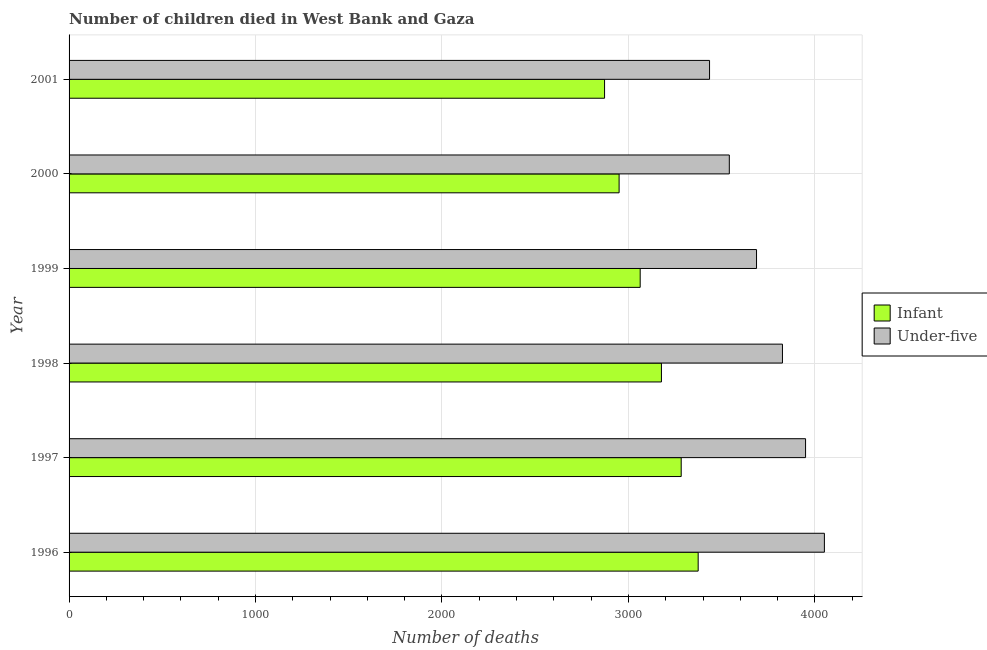Are the number of bars on each tick of the Y-axis equal?
Keep it short and to the point. Yes. How many bars are there on the 4th tick from the bottom?
Keep it short and to the point. 2. In how many cases, is the number of bars for a given year not equal to the number of legend labels?
Your response must be concise. 0. What is the number of under-five deaths in 1998?
Provide a succinct answer. 3826. Across all years, what is the maximum number of under-five deaths?
Make the answer very short. 4051. Across all years, what is the minimum number of infant deaths?
Your answer should be very brief. 2872. In which year was the number of infant deaths minimum?
Your response must be concise. 2001. What is the total number of infant deaths in the graph?
Offer a very short reply. 1.87e+04. What is the difference between the number of under-five deaths in 1996 and that in 2000?
Provide a short and direct response. 510. What is the difference between the number of under-five deaths in 1999 and the number of infant deaths in 2000?
Your response must be concise. 737. What is the average number of infant deaths per year?
Give a very brief answer. 3119.83. In the year 2000, what is the difference between the number of infant deaths and number of under-five deaths?
Provide a short and direct response. -591. In how many years, is the number of under-five deaths greater than 600 ?
Provide a succinct answer. 6. What is the ratio of the number of infant deaths in 2000 to that in 2001?
Your response must be concise. 1.03. Is the difference between the number of under-five deaths in 1996 and 2001 greater than the difference between the number of infant deaths in 1996 and 2001?
Make the answer very short. Yes. What is the difference between the highest and the second highest number of infant deaths?
Ensure brevity in your answer.  91. What is the difference between the highest and the lowest number of infant deaths?
Keep it short and to the point. 502. In how many years, is the number of under-five deaths greater than the average number of under-five deaths taken over all years?
Your answer should be very brief. 3. What does the 1st bar from the top in 1998 represents?
Your answer should be very brief. Under-five. What does the 2nd bar from the bottom in 1998 represents?
Give a very brief answer. Under-five. Are all the bars in the graph horizontal?
Your answer should be compact. Yes. Are the values on the major ticks of X-axis written in scientific E-notation?
Give a very brief answer. No. Does the graph contain any zero values?
Your answer should be very brief. No. Where does the legend appear in the graph?
Keep it short and to the point. Center right. How are the legend labels stacked?
Make the answer very short. Vertical. What is the title of the graph?
Make the answer very short. Number of children died in West Bank and Gaza. What is the label or title of the X-axis?
Make the answer very short. Number of deaths. What is the Number of deaths of Infant in 1996?
Keep it short and to the point. 3374. What is the Number of deaths of Under-five in 1996?
Your answer should be very brief. 4051. What is the Number of deaths in Infant in 1997?
Provide a short and direct response. 3283. What is the Number of deaths of Under-five in 1997?
Provide a short and direct response. 3950. What is the Number of deaths in Infant in 1998?
Offer a very short reply. 3177. What is the Number of deaths in Under-five in 1998?
Ensure brevity in your answer.  3826. What is the Number of deaths of Infant in 1999?
Ensure brevity in your answer.  3063. What is the Number of deaths in Under-five in 1999?
Offer a very short reply. 3687. What is the Number of deaths in Infant in 2000?
Offer a very short reply. 2950. What is the Number of deaths of Under-five in 2000?
Offer a terse response. 3541. What is the Number of deaths in Infant in 2001?
Keep it short and to the point. 2872. What is the Number of deaths of Under-five in 2001?
Give a very brief answer. 3435. Across all years, what is the maximum Number of deaths of Infant?
Your response must be concise. 3374. Across all years, what is the maximum Number of deaths in Under-five?
Your answer should be very brief. 4051. Across all years, what is the minimum Number of deaths of Infant?
Provide a succinct answer. 2872. Across all years, what is the minimum Number of deaths of Under-five?
Make the answer very short. 3435. What is the total Number of deaths in Infant in the graph?
Make the answer very short. 1.87e+04. What is the total Number of deaths in Under-five in the graph?
Offer a terse response. 2.25e+04. What is the difference between the Number of deaths of Infant in 1996 and that in 1997?
Your response must be concise. 91. What is the difference between the Number of deaths in Under-five in 1996 and that in 1997?
Offer a terse response. 101. What is the difference between the Number of deaths in Infant in 1996 and that in 1998?
Provide a short and direct response. 197. What is the difference between the Number of deaths of Under-five in 1996 and that in 1998?
Provide a short and direct response. 225. What is the difference between the Number of deaths in Infant in 1996 and that in 1999?
Offer a very short reply. 311. What is the difference between the Number of deaths of Under-five in 1996 and that in 1999?
Offer a terse response. 364. What is the difference between the Number of deaths of Infant in 1996 and that in 2000?
Make the answer very short. 424. What is the difference between the Number of deaths in Under-five in 1996 and that in 2000?
Give a very brief answer. 510. What is the difference between the Number of deaths of Infant in 1996 and that in 2001?
Ensure brevity in your answer.  502. What is the difference between the Number of deaths in Under-five in 1996 and that in 2001?
Ensure brevity in your answer.  616. What is the difference between the Number of deaths of Infant in 1997 and that in 1998?
Keep it short and to the point. 106. What is the difference between the Number of deaths in Under-five in 1997 and that in 1998?
Offer a very short reply. 124. What is the difference between the Number of deaths in Infant in 1997 and that in 1999?
Offer a terse response. 220. What is the difference between the Number of deaths in Under-five in 1997 and that in 1999?
Offer a terse response. 263. What is the difference between the Number of deaths in Infant in 1997 and that in 2000?
Your answer should be compact. 333. What is the difference between the Number of deaths in Under-five in 1997 and that in 2000?
Provide a succinct answer. 409. What is the difference between the Number of deaths in Infant in 1997 and that in 2001?
Offer a terse response. 411. What is the difference between the Number of deaths in Under-five in 1997 and that in 2001?
Ensure brevity in your answer.  515. What is the difference between the Number of deaths in Infant in 1998 and that in 1999?
Your answer should be very brief. 114. What is the difference between the Number of deaths of Under-five in 1998 and that in 1999?
Offer a very short reply. 139. What is the difference between the Number of deaths of Infant in 1998 and that in 2000?
Your answer should be compact. 227. What is the difference between the Number of deaths of Under-five in 1998 and that in 2000?
Provide a succinct answer. 285. What is the difference between the Number of deaths of Infant in 1998 and that in 2001?
Offer a very short reply. 305. What is the difference between the Number of deaths in Under-five in 1998 and that in 2001?
Offer a very short reply. 391. What is the difference between the Number of deaths in Infant in 1999 and that in 2000?
Give a very brief answer. 113. What is the difference between the Number of deaths of Under-five in 1999 and that in 2000?
Your response must be concise. 146. What is the difference between the Number of deaths of Infant in 1999 and that in 2001?
Offer a very short reply. 191. What is the difference between the Number of deaths in Under-five in 1999 and that in 2001?
Ensure brevity in your answer.  252. What is the difference between the Number of deaths of Infant in 2000 and that in 2001?
Your answer should be compact. 78. What is the difference between the Number of deaths of Under-five in 2000 and that in 2001?
Your response must be concise. 106. What is the difference between the Number of deaths of Infant in 1996 and the Number of deaths of Under-five in 1997?
Give a very brief answer. -576. What is the difference between the Number of deaths in Infant in 1996 and the Number of deaths in Under-five in 1998?
Give a very brief answer. -452. What is the difference between the Number of deaths of Infant in 1996 and the Number of deaths of Under-five in 1999?
Make the answer very short. -313. What is the difference between the Number of deaths of Infant in 1996 and the Number of deaths of Under-five in 2000?
Keep it short and to the point. -167. What is the difference between the Number of deaths of Infant in 1996 and the Number of deaths of Under-five in 2001?
Provide a short and direct response. -61. What is the difference between the Number of deaths in Infant in 1997 and the Number of deaths in Under-five in 1998?
Your response must be concise. -543. What is the difference between the Number of deaths of Infant in 1997 and the Number of deaths of Under-five in 1999?
Offer a terse response. -404. What is the difference between the Number of deaths in Infant in 1997 and the Number of deaths in Under-five in 2000?
Your response must be concise. -258. What is the difference between the Number of deaths of Infant in 1997 and the Number of deaths of Under-five in 2001?
Make the answer very short. -152. What is the difference between the Number of deaths of Infant in 1998 and the Number of deaths of Under-five in 1999?
Give a very brief answer. -510. What is the difference between the Number of deaths of Infant in 1998 and the Number of deaths of Under-five in 2000?
Provide a succinct answer. -364. What is the difference between the Number of deaths of Infant in 1998 and the Number of deaths of Under-five in 2001?
Provide a succinct answer. -258. What is the difference between the Number of deaths in Infant in 1999 and the Number of deaths in Under-five in 2000?
Keep it short and to the point. -478. What is the difference between the Number of deaths of Infant in 1999 and the Number of deaths of Under-five in 2001?
Your answer should be compact. -372. What is the difference between the Number of deaths in Infant in 2000 and the Number of deaths in Under-five in 2001?
Your answer should be very brief. -485. What is the average Number of deaths in Infant per year?
Provide a short and direct response. 3119.83. What is the average Number of deaths of Under-five per year?
Offer a very short reply. 3748.33. In the year 1996, what is the difference between the Number of deaths in Infant and Number of deaths in Under-five?
Keep it short and to the point. -677. In the year 1997, what is the difference between the Number of deaths in Infant and Number of deaths in Under-five?
Offer a very short reply. -667. In the year 1998, what is the difference between the Number of deaths of Infant and Number of deaths of Under-five?
Make the answer very short. -649. In the year 1999, what is the difference between the Number of deaths of Infant and Number of deaths of Under-five?
Ensure brevity in your answer.  -624. In the year 2000, what is the difference between the Number of deaths of Infant and Number of deaths of Under-five?
Provide a succinct answer. -591. In the year 2001, what is the difference between the Number of deaths of Infant and Number of deaths of Under-five?
Provide a succinct answer. -563. What is the ratio of the Number of deaths of Infant in 1996 to that in 1997?
Offer a terse response. 1.03. What is the ratio of the Number of deaths in Under-five in 1996 to that in 1997?
Make the answer very short. 1.03. What is the ratio of the Number of deaths of Infant in 1996 to that in 1998?
Make the answer very short. 1.06. What is the ratio of the Number of deaths in Under-five in 1996 to that in 1998?
Your response must be concise. 1.06. What is the ratio of the Number of deaths of Infant in 1996 to that in 1999?
Your response must be concise. 1.1. What is the ratio of the Number of deaths of Under-five in 1996 to that in 1999?
Ensure brevity in your answer.  1.1. What is the ratio of the Number of deaths in Infant in 1996 to that in 2000?
Keep it short and to the point. 1.14. What is the ratio of the Number of deaths in Under-five in 1996 to that in 2000?
Your response must be concise. 1.14. What is the ratio of the Number of deaths in Infant in 1996 to that in 2001?
Give a very brief answer. 1.17. What is the ratio of the Number of deaths in Under-five in 1996 to that in 2001?
Your response must be concise. 1.18. What is the ratio of the Number of deaths in Infant in 1997 to that in 1998?
Keep it short and to the point. 1.03. What is the ratio of the Number of deaths in Under-five in 1997 to that in 1998?
Your answer should be compact. 1.03. What is the ratio of the Number of deaths in Infant in 1997 to that in 1999?
Your response must be concise. 1.07. What is the ratio of the Number of deaths of Under-five in 1997 to that in 1999?
Ensure brevity in your answer.  1.07. What is the ratio of the Number of deaths of Infant in 1997 to that in 2000?
Provide a short and direct response. 1.11. What is the ratio of the Number of deaths of Under-five in 1997 to that in 2000?
Your response must be concise. 1.12. What is the ratio of the Number of deaths of Infant in 1997 to that in 2001?
Ensure brevity in your answer.  1.14. What is the ratio of the Number of deaths of Under-five in 1997 to that in 2001?
Make the answer very short. 1.15. What is the ratio of the Number of deaths of Infant in 1998 to that in 1999?
Keep it short and to the point. 1.04. What is the ratio of the Number of deaths in Under-five in 1998 to that in 1999?
Your answer should be compact. 1.04. What is the ratio of the Number of deaths in Infant in 1998 to that in 2000?
Your response must be concise. 1.08. What is the ratio of the Number of deaths of Under-five in 1998 to that in 2000?
Provide a short and direct response. 1.08. What is the ratio of the Number of deaths of Infant in 1998 to that in 2001?
Give a very brief answer. 1.11. What is the ratio of the Number of deaths in Under-five in 1998 to that in 2001?
Your response must be concise. 1.11. What is the ratio of the Number of deaths in Infant in 1999 to that in 2000?
Keep it short and to the point. 1.04. What is the ratio of the Number of deaths in Under-five in 1999 to that in 2000?
Your answer should be very brief. 1.04. What is the ratio of the Number of deaths of Infant in 1999 to that in 2001?
Ensure brevity in your answer.  1.07. What is the ratio of the Number of deaths in Under-five in 1999 to that in 2001?
Provide a succinct answer. 1.07. What is the ratio of the Number of deaths in Infant in 2000 to that in 2001?
Provide a succinct answer. 1.03. What is the ratio of the Number of deaths in Under-five in 2000 to that in 2001?
Give a very brief answer. 1.03. What is the difference between the highest and the second highest Number of deaths in Infant?
Make the answer very short. 91. What is the difference between the highest and the second highest Number of deaths of Under-five?
Give a very brief answer. 101. What is the difference between the highest and the lowest Number of deaths of Infant?
Your answer should be very brief. 502. What is the difference between the highest and the lowest Number of deaths in Under-five?
Your answer should be very brief. 616. 